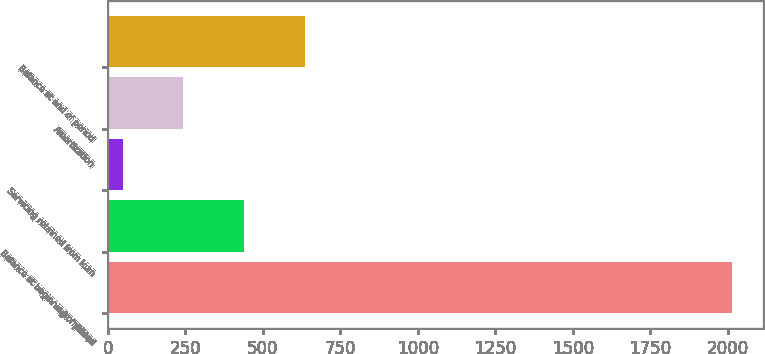Convert chart to OTSL. <chart><loc_0><loc_0><loc_500><loc_500><bar_chart><fcel>in millions<fcel>Balance at beginning of period<fcel>Servicing retained from loan<fcel>Amortization<fcel>Balance at end of period<nl><fcel>2013<fcel>441<fcel>48<fcel>244.5<fcel>637.5<nl></chart> 